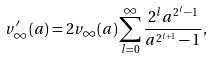<formula> <loc_0><loc_0><loc_500><loc_500>v ^ { \prime } _ { \infty } ( a ) = 2 v _ { \infty } ( a ) \sum _ { l = 0 } ^ { \infty } \frac { 2 ^ { l } a ^ { 2 ^ { l } - 1 } } { a ^ { 2 ^ { l + 1 } } - 1 } ,</formula> 